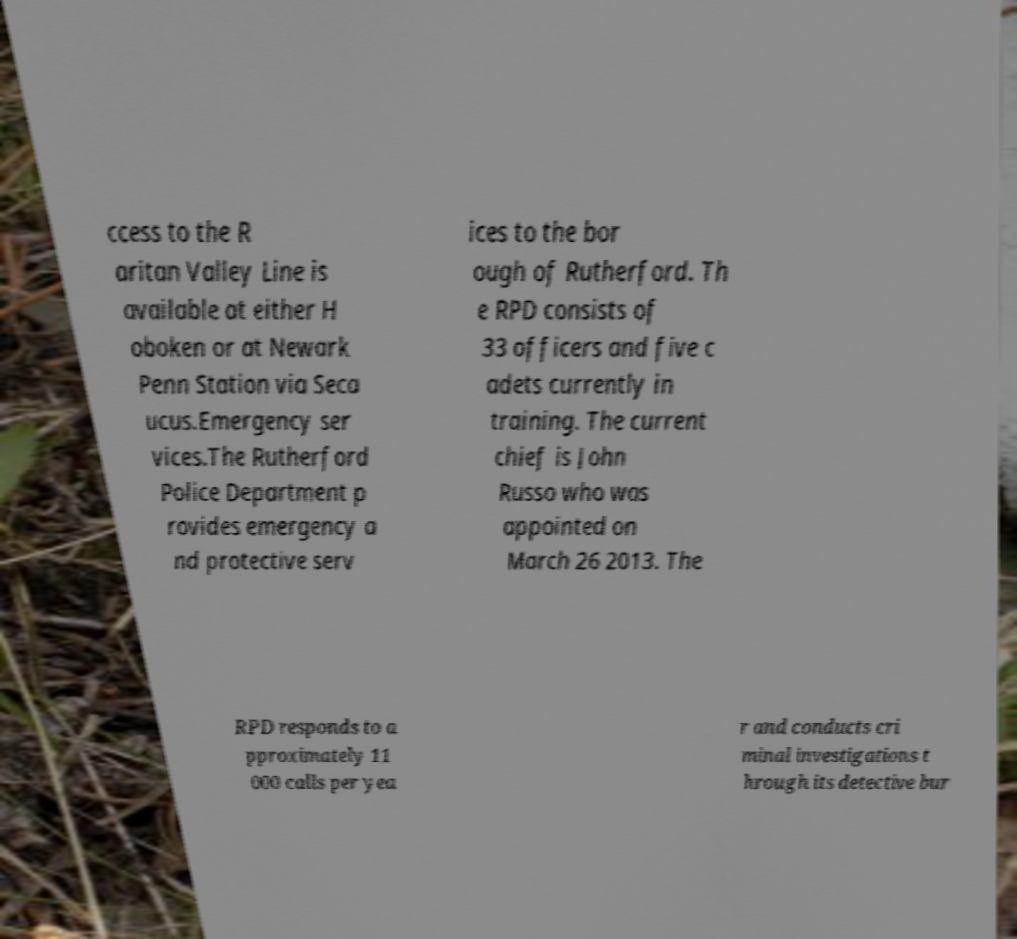There's text embedded in this image that I need extracted. Can you transcribe it verbatim? ccess to the R aritan Valley Line is available at either H oboken or at Newark Penn Station via Seca ucus.Emergency ser vices.The Rutherford Police Department p rovides emergency a nd protective serv ices to the bor ough of Rutherford. Th e RPD consists of 33 officers and five c adets currently in training. The current chief is John Russo who was appointed on March 26 2013. The RPD responds to a pproximately 11 000 calls per yea r and conducts cri minal investigations t hrough its detective bur 